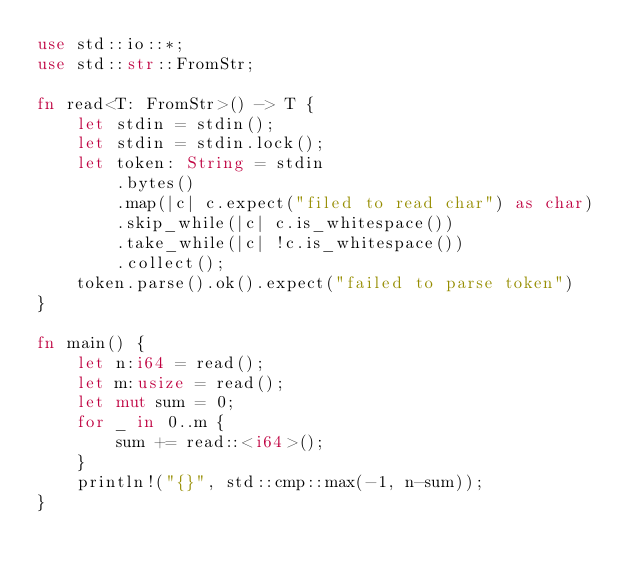Convert code to text. <code><loc_0><loc_0><loc_500><loc_500><_Rust_>use std::io::*;
use std::str::FromStr;

fn read<T: FromStr>() -> T {
    let stdin = stdin();
    let stdin = stdin.lock();
    let token: String = stdin
        .bytes()
        .map(|c| c.expect("filed to read char") as char)
        .skip_while(|c| c.is_whitespace())
        .take_while(|c| !c.is_whitespace())
        .collect();
    token.parse().ok().expect("failed to parse token")
}

fn main() {
    let n:i64 = read();
    let m:usize = read();
    let mut sum = 0;
    for _ in 0..m {
        sum += read::<i64>();
    }
    println!("{}", std::cmp::max(-1, n-sum));
}
</code> 